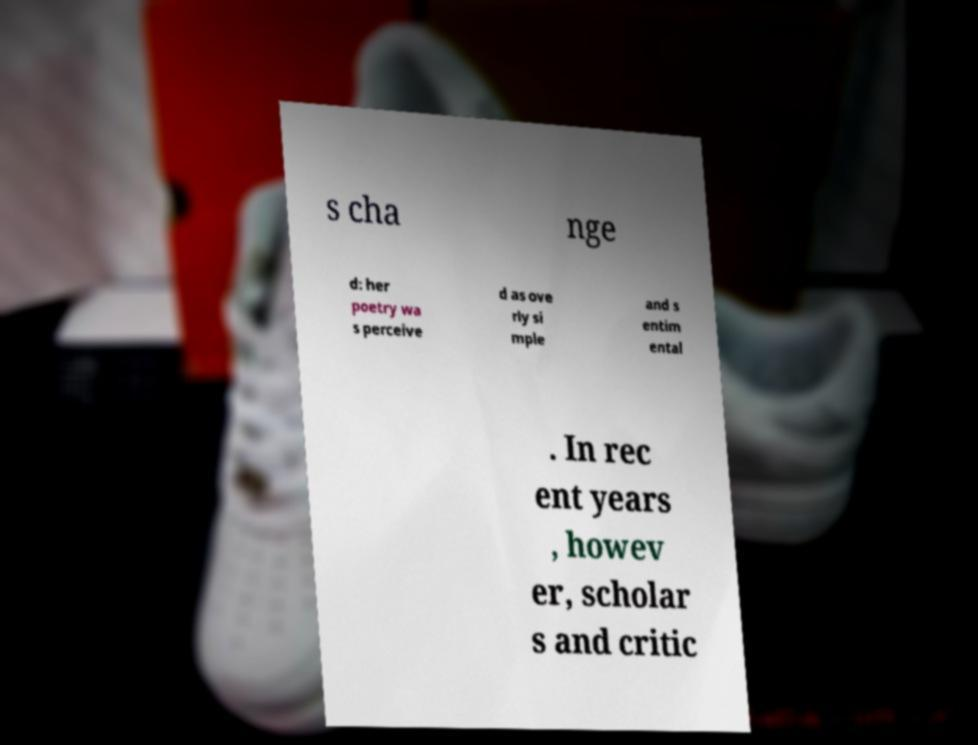What messages or text are displayed in this image? I need them in a readable, typed format. s cha nge d: her poetry wa s perceive d as ove rly si mple and s entim ental . In rec ent years , howev er, scholar s and critic 